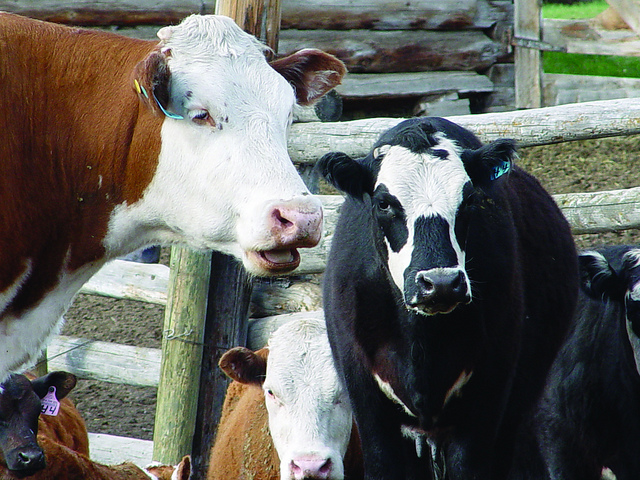Who put the tag on the cow's ear?
A. alien
B. another cow
C. dog
D. human The correct answer is D. human. Ear tagging is a common practice in livestock management carried out by farmers or animal handlers to identify and keep track of animals. It aids in health management, breeding, and ensuring traceability of the animals. 